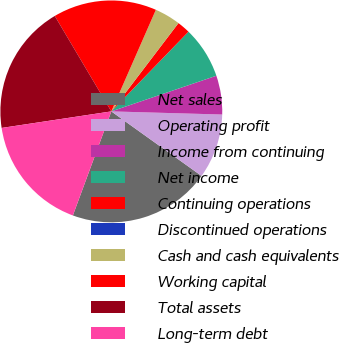Convert chart to OTSL. <chart><loc_0><loc_0><loc_500><loc_500><pie_chart><fcel>Net sales<fcel>Operating profit<fcel>Income from continuing<fcel>Net income<fcel>Continuing operations<fcel>Discontinued operations<fcel>Cash and cash equivalents<fcel>Working capital<fcel>Total assets<fcel>Long-term debt<nl><fcel>20.75%<fcel>9.43%<fcel>5.66%<fcel>7.55%<fcel>1.89%<fcel>0.0%<fcel>3.77%<fcel>15.09%<fcel>18.87%<fcel>16.98%<nl></chart> 